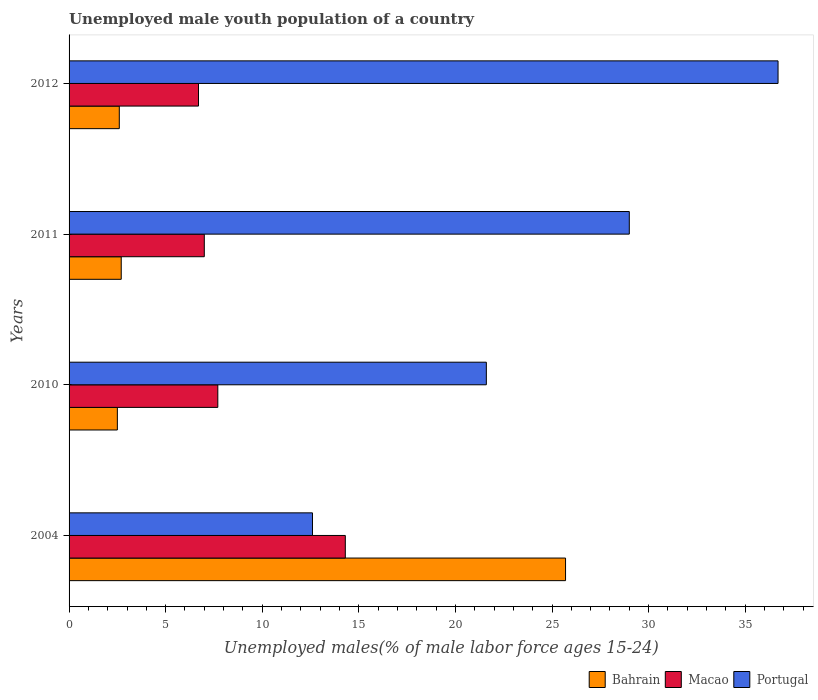How many different coloured bars are there?
Keep it short and to the point. 3. How many groups of bars are there?
Provide a short and direct response. 4. Are the number of bars per tick equal to the number of legend labels?
Your answer should be compact. Yes. Are the number of bars on each tick of the Y-axis equal?
Give a very brief answer. Yes. How many bars are there on the 3rd tick from the top?
Keep it short and to the point. 3. In how many cases, is the number of bars for a given year not equal to the number of legend labels?
Your answer should be very brief. 0. What is the percentage of unemployed male youth population in Macao in 2011?
Give a very brief answer. 7. Across all years, what is the maximum percentage of unemployed male youth population in Bahrain?
Your answer should be compact. 25.7. Across all years, what is the minimum percentage of unemployed male youth population in Macao?
Give a very brief answer. 6.7. What is the total percentage of unemployed male youth population in Macao in the graph?
Provide a short and direct response. 35.7. What is the difference between the percentage of unemployed male youth population in Bahrain in 2004 and that in 2010?
Make the answer very short. 23.2. What is the difference between the percentage of unemployed male youth population in Macao in 2010 and the percentage of unemployed male youth population in Portugal in 2011?
Make the answer very short. -21.3. What is the average percentage of unemployed male youth population in Portugal per year?
Offer a terse response. 24.98. In the year 2012, what is the difference between the percentage of unemployed male youth population in Macao and percentage of unemployed male youth population in Bahrain?
Give a very brief answer. 4.1. In how many years, is the percentage of unemployed male youth population in Portugal greater than 20 %?
Make the answer very short. 3. What is the ratio of the percentage of unemployed male youth population in Bahrain in 2010 to that in 2012?
Provide a short and direct response. 0.96. Is the difference between the percentage of unemployed male youth population in Macao in 2011 and 2012 greater than the difference between the percentage of unemployed male youth population in Bahrain in 2011 and 2012?
Make the answer very short. Yes. What is the difference between the highest and the second highest percentage of unemployed male youth population in Macao?
Offer a very short reply. 6.6. What is the difference between the highest and the lowest percentage of unemployed male youth population in Portugal?
Your response must be concise. 24.1. Is the sum of the percentage of unemployed male youth population in Bahrain in 2004 and 2010 greater than the maximum percentage of unemployed male youth population in Portugal across all years?
Make the answer very short. No. What does the 2nd bar from the top in 2010 represents?
Offer a very short reply. Macao. What does the 2nd bar from the bottom in 2011 represents?
Provide a short and direct response. Macao. How many bars are there?
Provide a succinct answer. 12. What is the difference between two consecutive major ticks on the X-axis?
Offer a very short reply. 5. Does the graph contain any zero values?
Offer a very short reply. No. Where does the legend appear in the graph?
Your answer should be compact. Bottom right. How many legend labels are there?
Provide a short and direct response. 3. What is the title of the graph?
Your response must be concise. Unemployed male youth population of a country. Does "Belgium" appear as one of the legend labels in the graph?
Your answer should be compact. No. What is the label or title of the X-axis?
Offer a very short reply. Unemployed males(% of male labor force ages 15-24). What is the Unemployed males(% of male labor force ages 15-24) of Bahrain in 2004?
Give a very brief answer. 25.7. What is the Unemployed males(% of male labor force ages 15-24) in Macao in 2004?
Offer a terse response. 14.3. What is the Unemployed males(% of male labor force ages 15-24) in Portugal in 2004?
Your answer should be very brief. 12.6. What is the Unemployed males(% of male labor force ages 15-24) of Bahrain in 2010?
Your answer should be compact. 2.5. What is the Unemployed males(% of male labor force ages 15-24) in Macao in 2010?
Provide a succinct answer. 7.7. What is the Unemployed males(% of male labor force ages 15-24) in Portugal in 2010?
Your answer should be very brief. 21.6. What is the Unemployed males(% of male labor force ages 15-24) in Bahrain in 2011?
Provide a short and direct response. 2.7. What is the Unemployed males(% of male labor force ages 15-24) in Macao in 2011?
Make the answer very short. 7. What is the Unemployed males(% of male labor force ages 15-24) of Portugal in 2011?
Your answer should be compact. 29. What is the Unemployed males(% of male labor force ages 15-24) of Bahrain in 2012?
Give a very brief answer. 2.6. What is the Unemployed males(% of male labor force ages 15-24) in Macao in 2012?
Ensure brevity in your answer.  6.7. What is the Unemployed males(% of male labor force ages 15-24) of Portugal in 2012?
Keep it short and to the point. 36.7. Across all years, what is the maximum Unemployed males(% of male labor force ages 15-24) of Bahrain?
Provide a succinct answer. 25.7. Across all years, what is the maximum Unemployed males(% of male labor force ages 15-24) of Macao?
Give a very brief answer. 14.3. Across all years, what is the maximum Unemployed males(% of male labor force ages 15-24) in Portugal?
Keep it short and to the point. 36.7. Across all years, what is the minimum Unemployed males(% of male labor force ages 15-24) in Bahrain?
Ensure brevity in your answer.  2.5. Across all years, what is the minimum Unemployed males(% of male labor force ages 15-24) in Macao?
Your answer should be very brief. 6.7. Across all years, what is the minimum Unemployed males(% of male labor force ages 15-24) of Portugal?
Provide a succinct answer. 12.6. What is the total Unemployed males(% of male labor force ages 15-24) in Bahrain in the graph?
Make the answer very short. 33.5. What is the total Unemployed males(% of male labor force ages 15-24) of Macao in the graph?
Your answer should be compact. 35.7. What is the total Unemployed males(% of male labor force ages 15-24) of Portugal in the graph?
Provide a short and direct response. 99.9. What is the difference between the Unemployed males(% of male labor force ages 15-24) in Bahrain in 2004 and that in 2010?
Offer a terse response. 23.2. What is the difference between the Unemployed males(% of male labor force ages 15-24) of Bahrain in 2004 and that in 2011?
Keep it short and to the point. 23. What is the difference between the Unemployed males(% of male labor force ages 15-24) of Macao in 2004 and that in 2011?
Your answer should be compact. 7.3. What is the difference between the Unemployed males(% of male labor force ages 15-24) of Portugal in 2004 and that in 2011?
Your answer should be very brief. -16.4. What is the difference between the Unemployed males(% of male labor force ages 15-24) in Bahrain in 2004 and that in 2012?
Provide a succinct answer. 23.1. What is the difference between the Unemployed males(% of male labor force ages 15-24) of Macao in 2004 and that in 2012?
Your response must be concise. 7.6. What is the difference between the Unemployed males(% of male labor force ages 15-24) in Portugal in 2004 and that in 2012?
Make the answer very short. -24.1. What is the difference between the Unemployed males(% of male labor force ages 15-24) in Bahrain in 2010 and that in 2011?
Keep it short and to the point. -0.2. What is the difference between the Unemployed males(% of male labor force ages 15-24) of Macao in 2010 and that in 2011?
Your response must be concise. 0.7. What is the difference between the Unemployed males(% of male labor force ages 15-24) of Portugal in 2010 and that in 2011?
Offer a very short reply. -7.4. What is the difference between the Unemployed males(% of male labor force ages 15-24) in Macao in 2010 and that in 2012?
Give a very brief answer. 1. What is the difference between the Unemployed males(% of male labor force ages 15-24) in Portugal in 2010 and that in 2012?
Provide a succinct answer. -15.1. What is the difference between the Unemployed males(% of male labor force ages 15-24) in Macao in 2011 and that in 2012?
Your response must be concise. 0.3. What is the difference between the Unemployed males(% of male labor force ages 15-24) of Portugal in 2011 and that in 2012?
Provide a short and direct response. -7.7. What is the difference between the Unemployed males(% of male labor force ages 15-24) of Bahrain in 2004 and the Unemployed males(% of male labor force ages 15-24) of Portugal in 2010?
Offer a terse response. 4.1. What is the difference between the Unemployed males(% of male labor force ages 15-24) in Bahrain in 2004 and the Unemployed males(% of male labor force ages 15-24) in Portugal in 2011?
Provide a short and direct response. -3.3. What is the difference between the Unemployed males(% of male labor force ages 15-24) in Macao in 2004 and the Unemployed males(% of male labor force ages 15-24) in Portugal in 2011?
Keep it short and to the point. -14.7. What is the difference between the Unemployed males(% of male labor force ages 15-24) in Bahrain in 2004 and the Unemployed males(% of male labor force ages 15-24) in Macao in 2012?
Your answer should be very brief. 19. What is the difference between the Unemployed males(% of male labor force ages 15-24) of Macao in 2004 and the Unemployed males(% of male labor force ages 15-24) of Portugal in 2012?
Provide a succinct answer. -22.4. What is the difference between the Unemployed males(% of male labor force ages 15-24) in Bahrain in 2010 and the Unemployed males(% of male labor force ages 15-24) in Macao in 2011?
Give a very brief answer. -4.5. What is the difference between the Unemployed males(% of male labor force ages 15-24) in Bahrain in 2010 and the Unemployed males(% of male labor force ages 15-24) in Portugal in 2011?
Provide a short and direct response. -26.5. What is the difference between the Unemployed males(% of male labor force ages 15-24) of Macao in 2010 and the Unemployed males(% of male labor force ages 15-24) of Portugal in 2011?
Keep it short and to the point. -21.3. What is the difference between the Unemployed males(% of male labor force ages 15-24) of Bahrain in 2010 and the Unemployed males(% of male labor force ages 15-24) of Portugal in 2012?
Make the answer very short. -34.2. What is the difference between the Unemployed males(% of male labor force ages 15-24) of Bahrain in 2011 and the Unemployed males(% of male labor force ages 15-24) of Macao in 2012?
Keep it short and to the point. -4. What is the difference between the Unemployed males(% of male labor force ages 15-24) in Bahrain in 2011 and the Unemployed males(% of male labor force ages 15-24) in Portugal in 2012?
Offer a very short reply. -34. What is the difference between the Unemployed males(% of male labor force ages 15-24) of Macao in 2011 and the Unemployed males(% of male labor force ages 15-24) of Portugal in 2012?
Ensure brevity in your answer.  -29.7. What is the average Unemployed males(% of male labor force ages 15-24) in Bahrain per year?
Your response must be concise. 8.38. What is the average Unemployed males(% of male labor force ages 15-24) of Macao per year?
Your answer should be compact. 8.93. What is the average Unemployed males(% of male labor force ages 15-24) of Portugal per year?
Offer a terse response. 24.98. In the year 2004, what is the difference between the Unemployed males(% of male labor force ages 15-24) of Bahrain and Unemployed males(% of male labor force ages 15-24) of Portugal?
Your answer should be very brief. 13.1. In the year 2004, what is the difference between the Unemployed males(% of male labor force ages 15-24) of Macao and Unemployed males(% of male labor force ages 15-24) of Portugal?
Your answer should be compact. 1.7. In the year 2010, what is the difference between the Unemployed males(% of male labor force ages 15-24) in Bahrain and Unemployed males(% of male labor force ages 15-24) in Portugal?
Provide a succinct answer. -19.1. In the year 2011, what is the difference between the Unemployed males(% of male labor force ages 15-24) of Bahrain and Unemployed males(% of male labor force ages 15-24) of Portugal?
Make the answer very short. -26.3. In the year 2012, what is the difference between the Unemployed males(% of male labor force ages 15-24) of Bahrain and Unemployed males(% of male labor force ages 15-24) of Macao?
Offer a very short reply. -4.1. In the year 2012, what is the difference between the Unemployed males(% of male labor force ages 15-24) of Bahrain and Unemployed males(% of male labor force ages 15-24) of Portugal?
Make the answer very short. -34.1. In the year 2012, what is the difference between the Unemployed males(% of male labor force ages 15-24) in Macao and Unemployed males(% of male labor force ages 15-24) in Portugal?
Your answer should be very brief. -30. What is the ratio of the Unemployed males(% of male labor force ages 15-24) in Bahrain in 2004 to that in 2010?
Your answer should be compact. 10.28. What is the ratio of the Unemployed males(% of male labor force ages 15-24) in Macao in 2004 to that in 2010?
Your response must be concise. 1.86. What is the ratio of the Unemployed males(% of male labor force ages 15-24) in Portugal in 2004 to that in 2010?
Ensure brevity in your answer.  0.58. What is the ratio of the Unemployed males(% of male labor force ages 15-24) in Bahrain in 2004 to that in 2011?
Your answer should be very brief. 9.52. What is the ratio of the Unemployed males(% of male labor force ages 15-24) in Macao in 2004 to that in 2011?
Your response must be concise. 2.04. What is the ratio of the Unemployed males(% of male labor force ages 15-24) in Portugal in 2004 to that in 2011?
Offer a terse response. 0.43. What is the ratio of the Unemployed males(% of male labor force ages 15-24) of Bahrain in 2004 to that in 2012?
Your response must be concise. 9.88. What is the ratio of the Unemployed males(% of male labor force ages 15-24) of Macao in 2004 to that in 2012?
Offer a terse response. 2.13. What is the ratio of the Unemployed males(% of male labor force ages 15-24) of Portugal in 2004 to that in 2012?
Offer a terse response. 0.34. What is the ratio of the Unemployed males(% of male labor force ages 15-24) in Bahrain in 2010 to that in 2011?
Ensure brevity in your answer.  0.93. What is the ratio of the Unemployed males(% of male labor force ages 15-24) of Portugal in 2010 to that in 2011?
Ensure brevity in your answer.  0.74. What is the ratio of the Unemployed males(% of male labor force ages 15-24) in Bahrain in 2010 to that in 2012?
Ensure brevity in your answer.  0.96. What is the ratio of the Unemployed males(% of male labor force ages 15-24) of Macao in 2010 to that in 2012?
Offer a very short reply. 1.15. What is the ratio of the Unemployed males(% of male labor force ages 15-24) of Portugal in 2010 to that in 2012?
Keep it short and to the point. 0.59. What is the ratio of the Unemployed males(% of male labor force ages 15-24) in Macao in 2011 to that in 2012?
Give a very brief answer. 1.04. What is the ratio of the Unemployed males(% of male labor force ages 15-24) in Portugal in 2011 to that in 2012?
Make the answer very short. 0.79. What is the difference between the highest and the second highest Unemployed males(% of male labor force ages 15-24) in Bahrain?
Keep it short and to the point. 23. What is the difference between the highest and the second highest Unemployed males(% of male labor force ages 15-24) of Portugal?
Keep it short and to the point. 7.7. What is the difference between the highest and the lowest Unemployed males(% of male labor force ages 15-24) in Bahrain?
Your answer should be compact. 23.2. What is the difference between the highest and the lowest Unemployed males(% of male labor force ages 15-24) of Macao?
Give a very brief answer. 7.6. What is the difference between the highest and the lowest Unemployed males(% of male labor force ages 15-24) of Portugal?
Your answer should be compact. 24.1. 